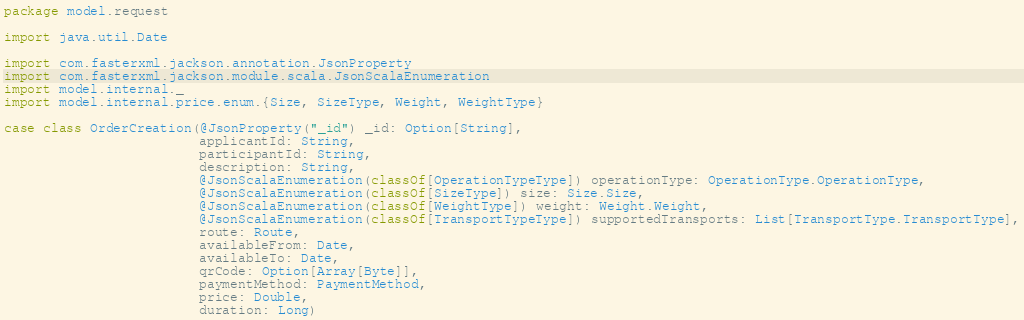<code> <loc_0><loc_0><loc_500><loc_500><_Scala_>package model.request

import java.util.Date

import com.fasterxml.jackson.annotation.JsonProperty
import com.fasterxml.jackson.module.scala.JsonScalaEnumeration
import model.internal._
import model.internal.price.enum.{Size, SizeType, Weight, WeightType}

case class OrderCreation(@JsonProperty("_id") _id: Option[String],
                         applicantId: String,
                         participantId: String,
                         description: String,
                         @JsonScalaEnumeration(classOf[OperationTypeType]) operationType: OperationType.OperationType,
                         @JsonScalaEnumeration(classOf[SizeType]) size: Size.Size,
                         @JsonScalaEnumeration(classOf[WeightType]) weight: Weight.Weight,
                         @JsonScalaEnumeration(classOf[TransportTypeType]) supportedTransports: List[TransportType.TransportType],
                         route: Route,
                         availableFrom: Date,
                         availableTo: Date,
                         qrCode: Option[Array[Byte]],
                         paymentMethod: PaymentMethod,
                         price: Double,
                         duration: Long)</code> 